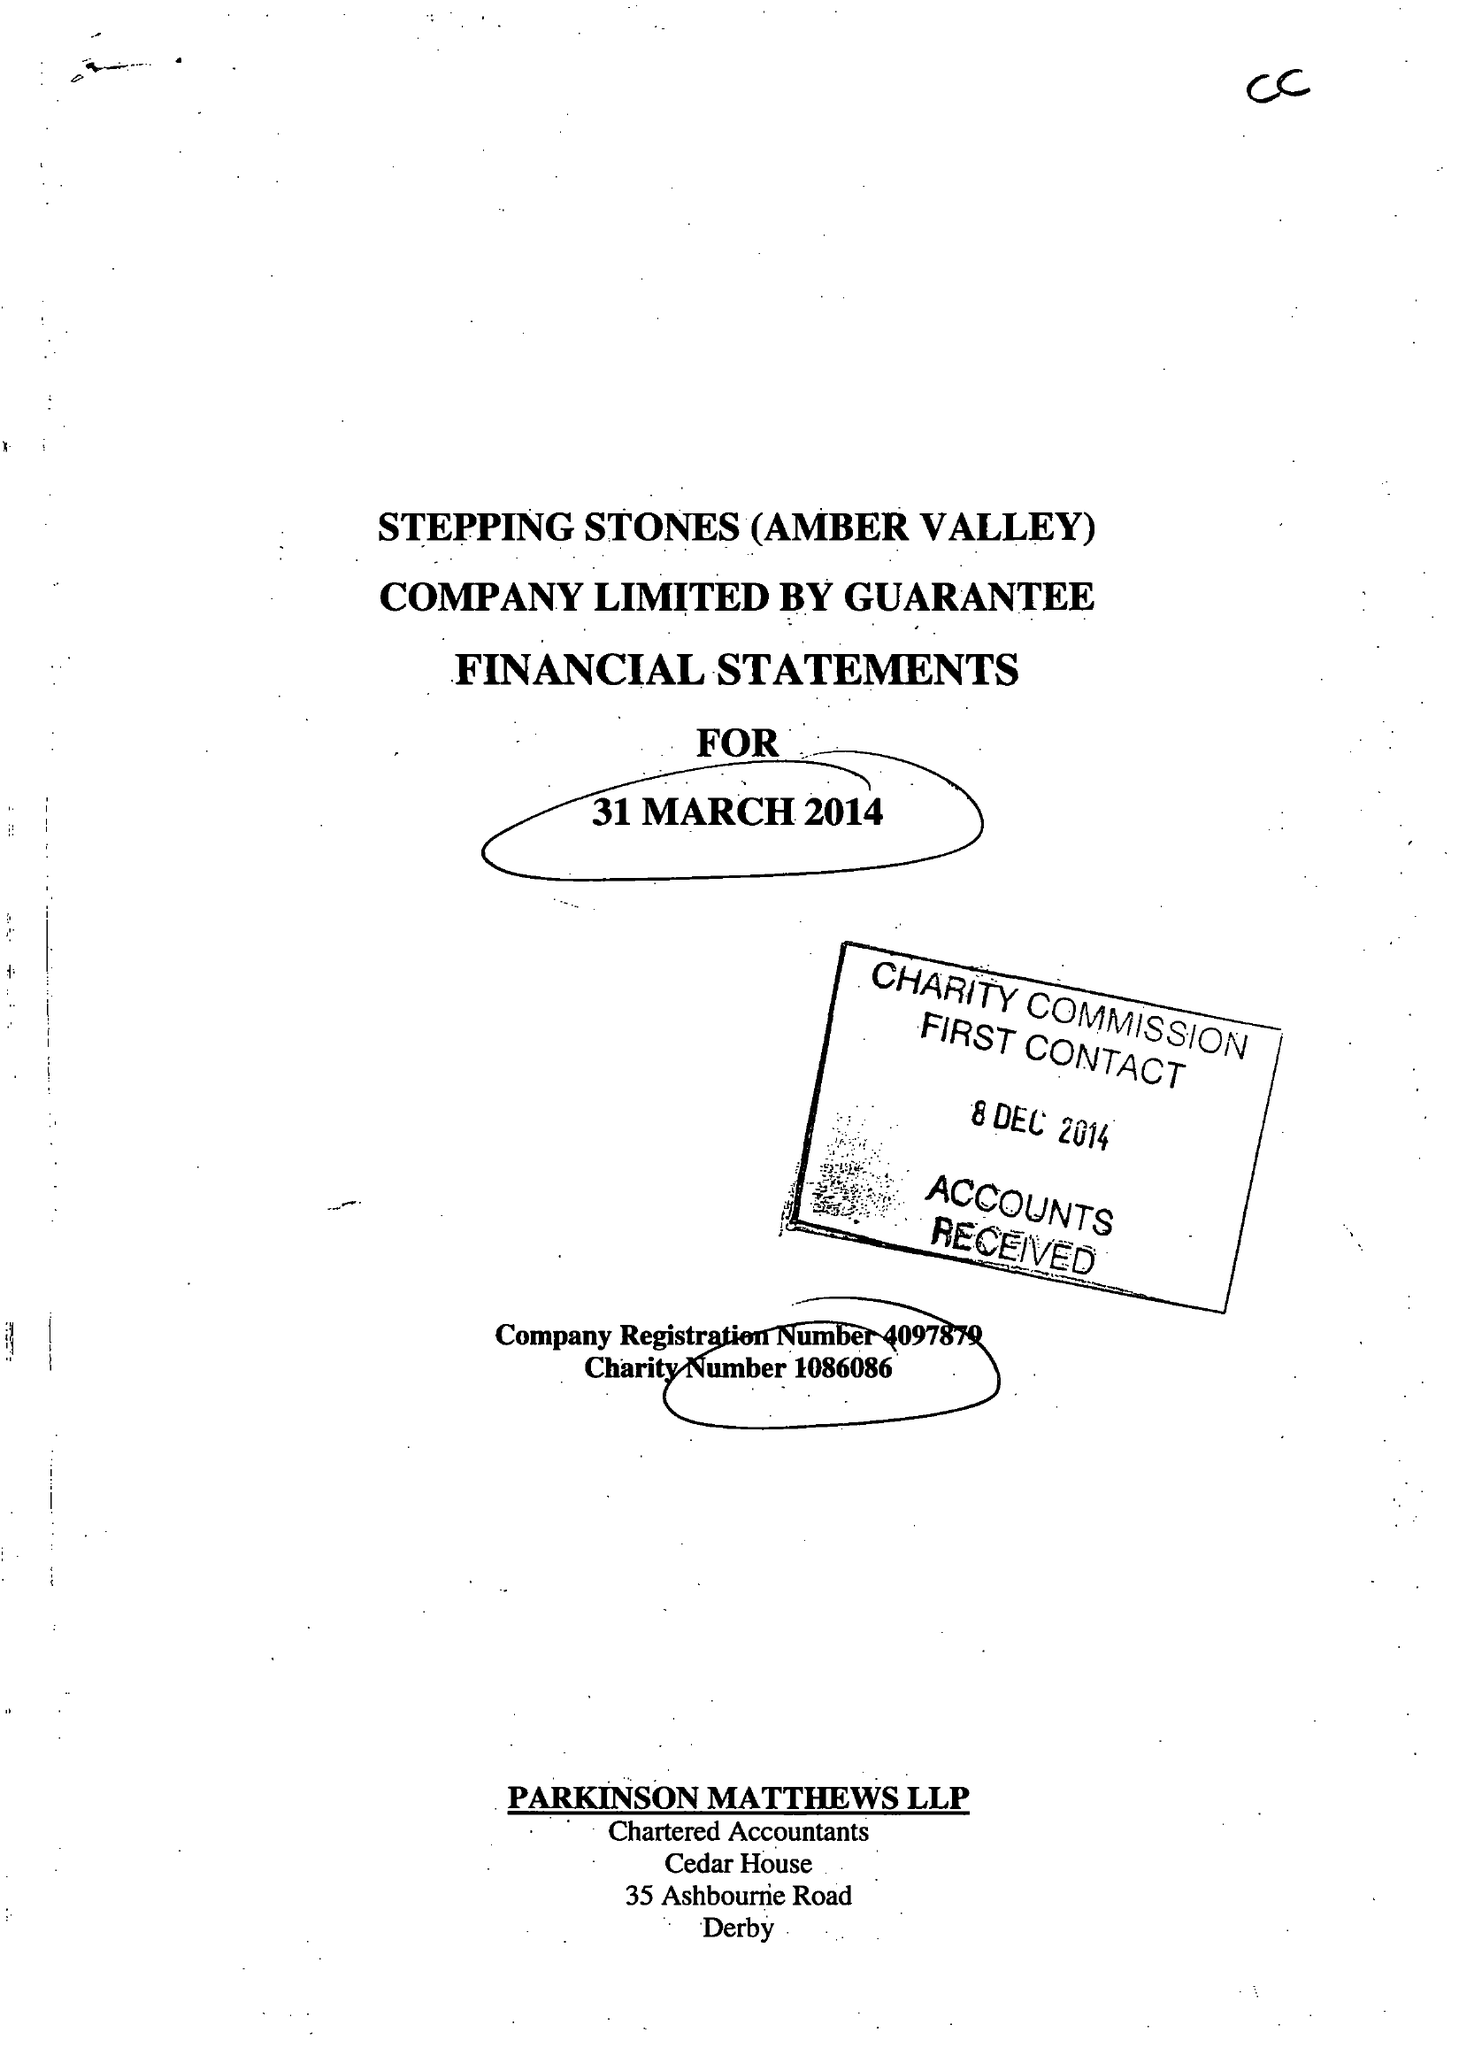What is the value for the report_date?
Answer the question using a single word or phrase. 2014-03-31 